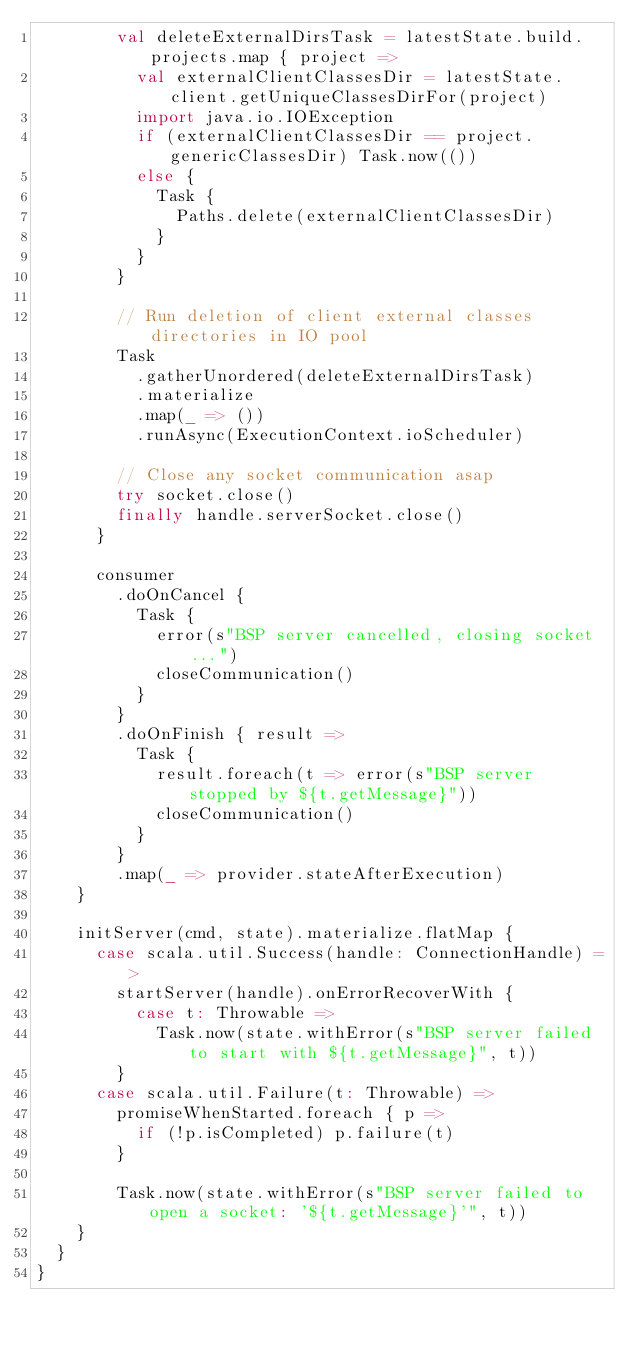<code> <loc_0><loc_0><loc_500><loc_500><_Scala_>        val deleteExternalDirsTask = latestState.build.projects.map { project =>
          val externalClientClassesDir = latestState.client.getUniqueClassesDirFor(project)
          import java.io.IOException
          if (externalClientClassesDir == project.genericClassesDir) Task.now(())
          else {
            Task {
              Paths.delete(externalClientClassesDir)
            }
          }
        }

        // Run deletion of client external classes directories in IO pool
        Task
          .gatherUnordered(deleteExternalDirsTask)
          .materialize
          .map(_ => ())
          .runAsync(ExecutionContext.ioScheduler)

        // Close any socket communication asap
        try socket.close()
        finally handle.serverSocket.close()
      }

      consumer
        .doOnCancel {
          Task {
            error(s"BSP server cancelled, closing socket...")
            closeCommunication()
          }
        }
        .doOnFinish { result =>
          Task {
            result.foreach(t => error(s"BSP server stopped by ${t.getMessage}"))
            closeCommunication()
          }
        }
        .map(_ => provider.stateAfterExecution)
    }

    initServer(cmd, state).materialize.flatMap {
      case scala.util.Success(handle: ConnectionHandle) =>
        startServer(handle).onErrorRecoverWith {
          case t: Throwable =>
            Task.now(state.withError(s"BSP server failed to start with ${t.getMessage}", t))
        }
      case scala.util.Failure(t: Throwable) =>
        promiseWhenStarted.foreach { p =>
          if (!p.isCompleted) p.failure(t)
        }

        Task.now(state.withError(s"BSP server failed to open a socket: '${t.getMessage}'", t))
    }
  }
}
</code> 